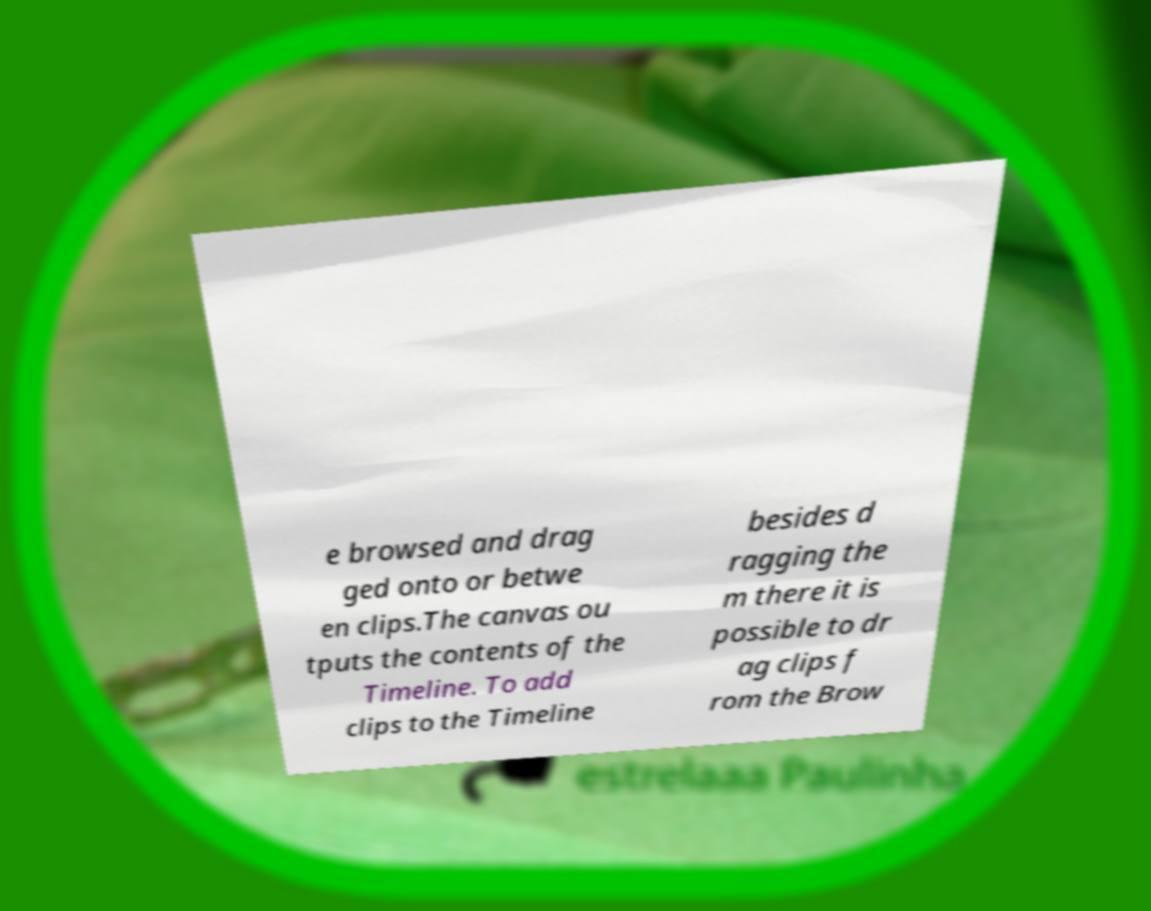Please read and relay the text visible in this image. What does it say? e browsed and drag ged onto or betwe en clips.The canvas ou tputs the contents of the Timeline. To add clips to the Timeline besides d ragging the m there it is possible to dr ag clips f rom the Brow 